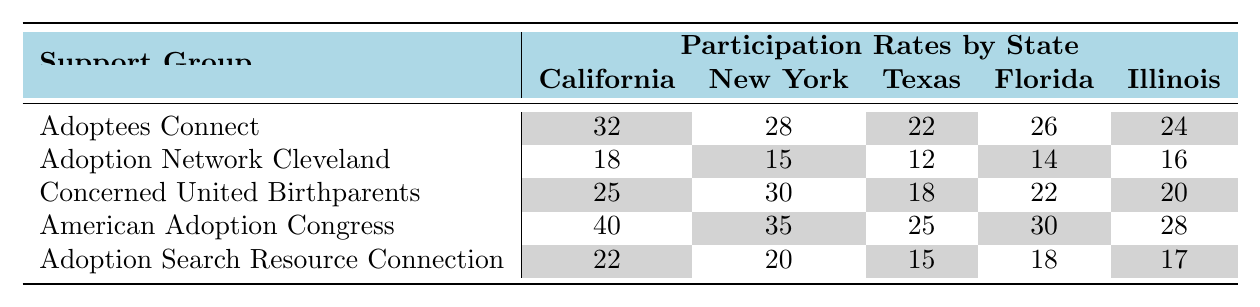What is the highest participation rate for the "American Adoption Congress" support group? Looking at the column for "American Adoption Congress," the rates are 40 (California), 35 (New York), 25 (Texas), 30 (Florida), and 28 (Illinois). The highest rate is 40 in California.
Answer: 40 Which support group had the lowest participation rate in Texas? The participation rates for Texas are: Adoptees Connect (22), Adoption Network Cleveland (12), Concerned United Birthparents (18), American Adoption Congress (25), and Adoption Search Resource Connection (15). The lowest participation rate is 12 for the Adoption Network Cleveland.
Answer: 12 How does the participation rate for "Concerned United Birthparents" in Florida compare to New York? In Florida, the rate is 22, while in New York it is 30. Comparing these two numbers, 22 is less than 30, indicating that participation is lower in Florida.
Answer: Lower in Florida What is the average participation rate for "Adoptees Connect" across all states? The participation rates for Adoptees Connect are 32 (California), 28 (New York), 22 (Texas), 26 (Florida), and 24 (Illinois). The sum of these rates is 32 + 28 + 22 + 26 + 24 = 132, and there are 5 states, so the average is 132/5 = 26.4.
Answer: 26.4 Is the participation rate for "Adoption Search Resource Connection" in Illinois higher than in California? The rate in Illinois is 17, and in California, it is 22. Since 17 is less than 22, it is not higher in Illinois.
Answer: No Which support group had a higher participation rate in California compared to Florida? In California, the rates are: Adoptees Connect (32), Adoption Network Cleveland (18), Concerned United Birthparents (25), American Adoption Congress (40), and Adoption Search Resource Connection (22). In Florida, the rates are: Adoptees Connect (26), Adoption Network Cleveland (14), Concerned United Birthparents (22), American Adoption Congress (30), and Adoption Search Resource Connection (18). The groups "Concerned United Birthparents" (25 > 22), "American Adoption Congress" (40 > 30), and "Adoptees Connect" (32 > 26) had higher participation in California than in Florida.
Answer: 3 groups What state had the highest overall average participation rate across all support groups? To find the overall average for each state: California (32+18+25+40+22=137/5=27.4), New York (28+15+30+35+20=128/5=25.6), Texas (22+12+18+25+15=92/5=18.4), Florida (26+14+22+30+18=110/5=22), Illinois (24+16+20+28+17=105/5=21). California has the highest average of 27.4.
Answer: California Which support group had a higher participation rate in New York than in Illinois? In New York: Adoptees Connect (28), Adoption Network Cleveland (15), Concerned United Birthparents (30), American Adoption Congress (35), and Adoption Search Resource Connection (20). In Illinois: Adoptees Connect (24), Adoption Network Cleveland (16), Concerned United Birthparents (20), American Adoption Congress (28), and Adoption Search Resource Connection (17). The groups with higher rates in New York are "Adoptees Connect" (28 > 24), "Concerned United Birthparents" (30 > 20), "American Adoption Congress" (35 > 28).
Answer: 3 groups Which state shows the largest difference in participation rates for "Adoption Network Cleveland" compared to "American Adoption Congress"? For Adoption Network Cleveland the rates are: California (18), New York (15), Texas (12), Florida (14), Illinois (16). For American Adoption Congress: California (40), New York (35), Texas (25), Florida (30), Illinois (28). The differences are: California (40-18=22), New York (35-15=20), Texas (25-12=13), Florida (30-14=16), Illinois (28-16=12). The largest difference is 22 in California.
Answer: 22 